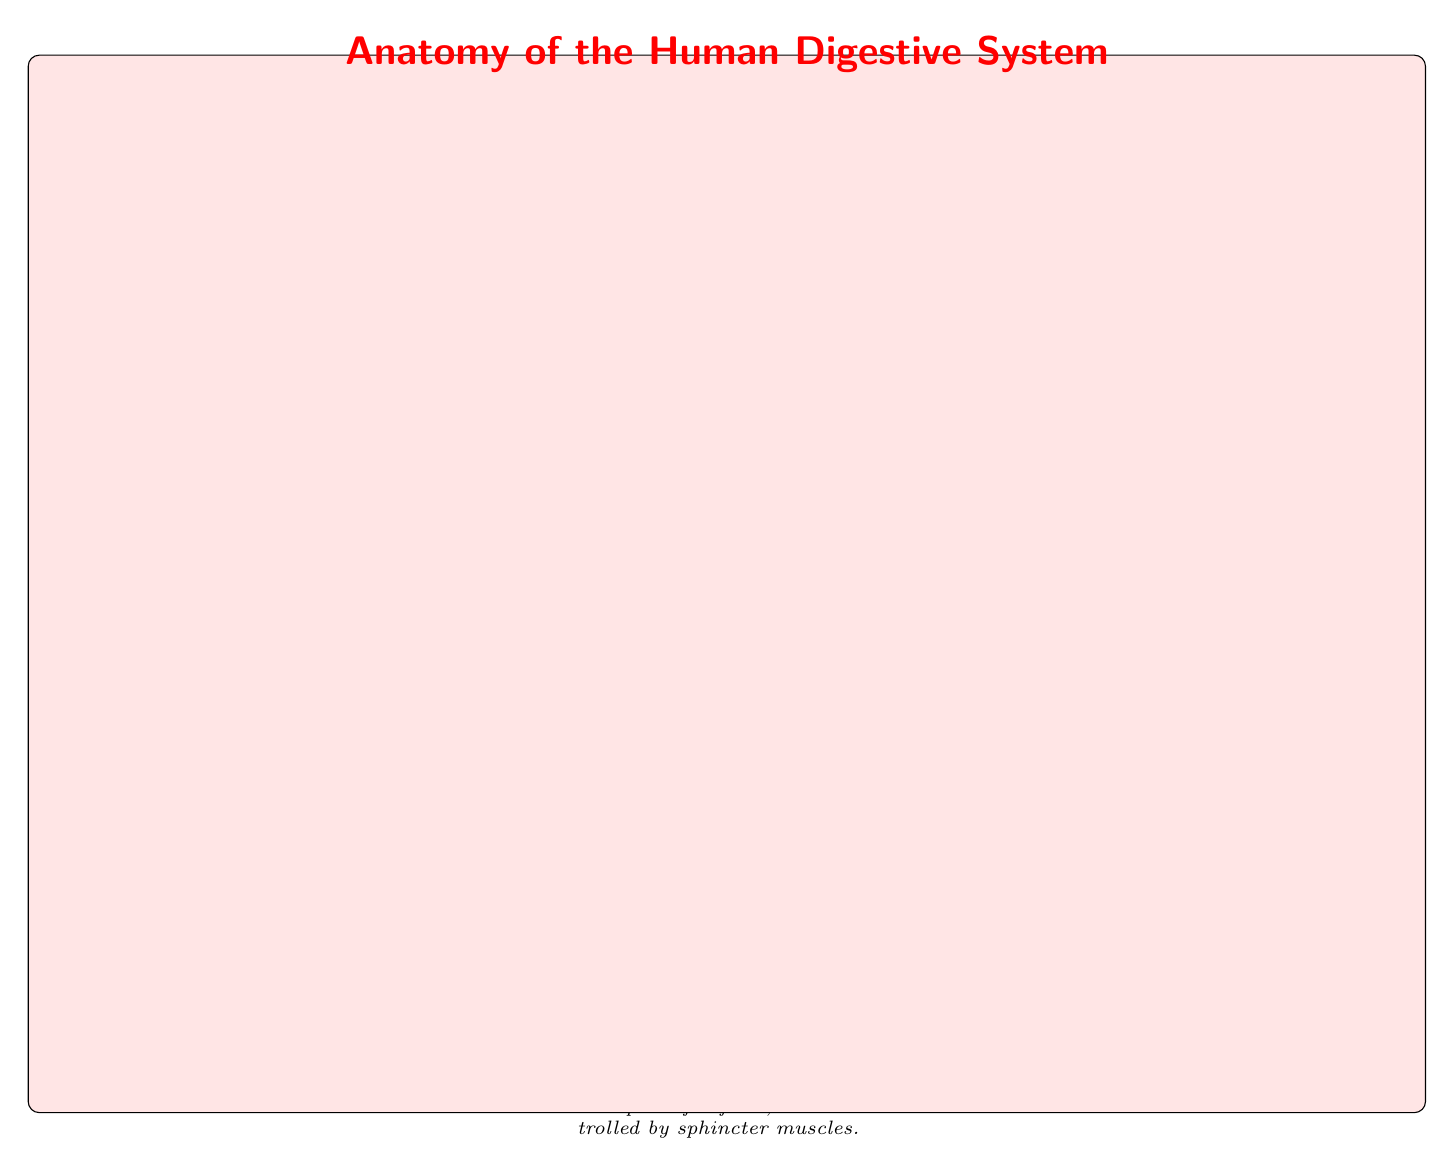What is the first organ in the digestive system? The first organ listed in the diagram is the mouth, which is indicated at the top. It is the entry point for food where mechanical breakdown begins with chewing.
Answer: Mouth How many organs are included in the diagram? By counting each organ node represented in the diagram, we find a total of 10 organs, each clearly labeled.
Answer: 10 What connects the throat to the stomach? The diagram specifies that the esophagus is the muscular tube that connects the throat to the stomach, based on its placement and description.
Answer: Esophagus What organ produces bile? The liver is specifically mentioned in the diagram as the organ that produces bile to help break down fats, as indicated in its description.
Answer: Liver What is the function of the pancreas? The pancreas has multiple functions including producing digestive enzymes and bicarbonate, as well as regulating blood sugar levels; all this information is consolidated in its description.
Answer: Produces digestive enzymes and regulates blood sugar levels Where does nutrient absorption primarily occur? According to the diagram, the small intestine is specified as the primary site for nutrient absorption, which is directly stated in its function description.
Answer: Small Intestine Which organ stores and concentrates bile? The gallbladder is explicitly described in the diagram as the organ that stores and concentrates bile, which is highlighted in its section.
Answer: Gallbladder What is the last organ in the digestive system? The last organ indicated in the diagram is the anus, which is the exit point for feces and is located at the bottom of the structure.
Answer: Anus Explain the process food goes through from the mouth to the small intestine. Starting at the mouth, food is chewed and mixed with saliva from the salivary glands. It then moves down the esophagus to the stomach, where it is churned and mixed with acids and enzymes. Next, the food passes into the small intestine, where further digestion occurs and nutrients are absorbed. Each step follows a progression down the diagram.
Answer: Mouth → Esophagus → Stomach → Small Intestine 